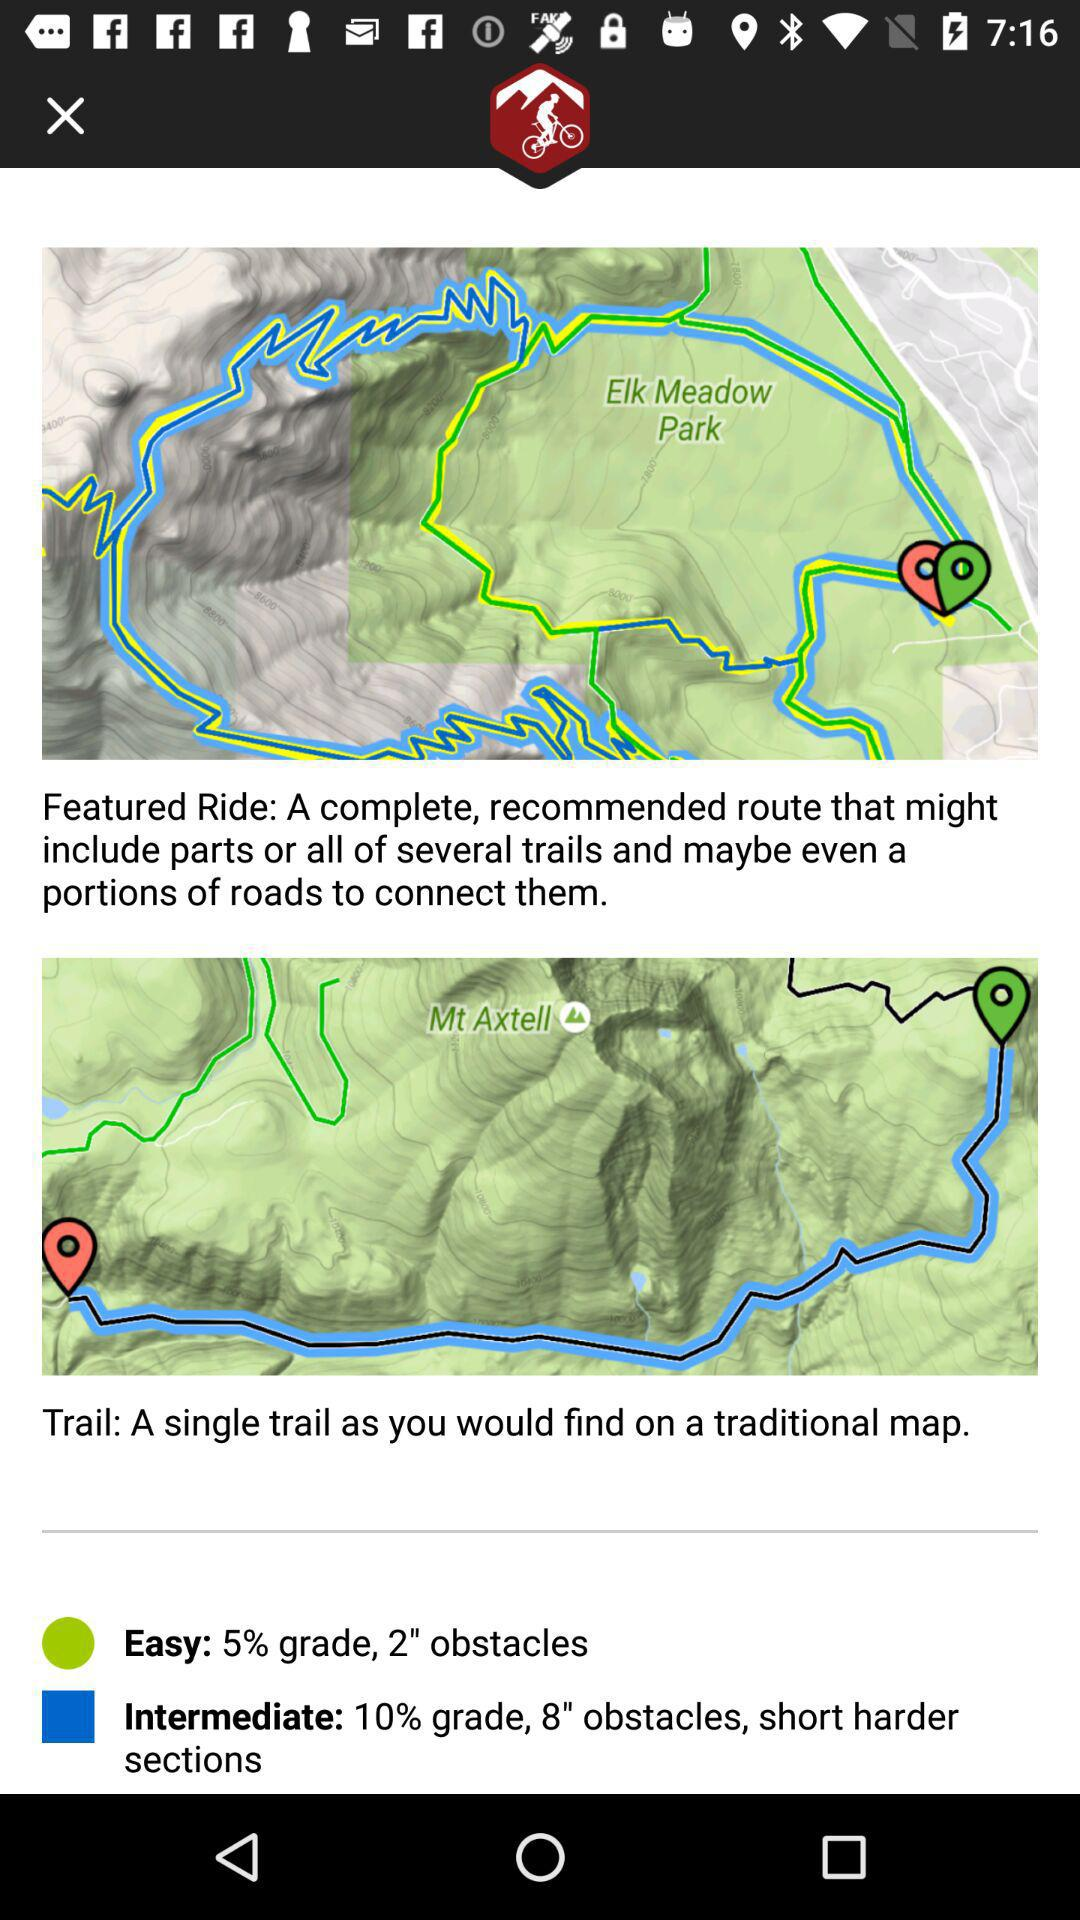What is the number of obstacles in easy trails?
When the provided information is insufficient, respond with <no answer>. <no answer> 